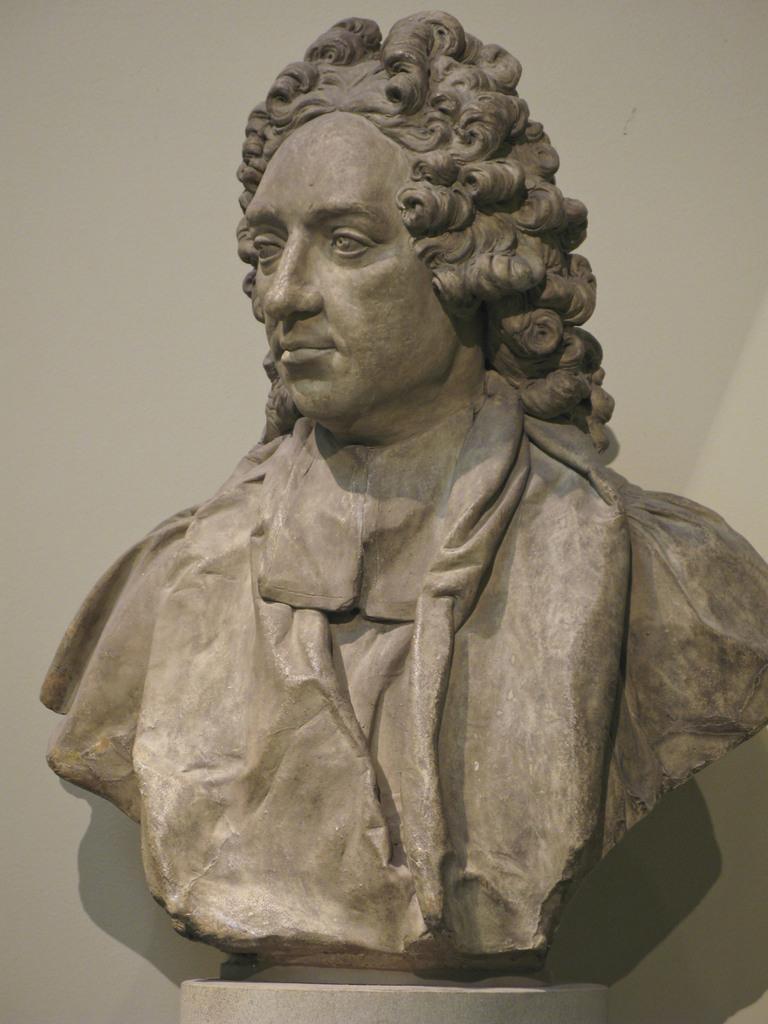Please provide a concise description of this image. This image consists of a statue. It is the statue of a man. 